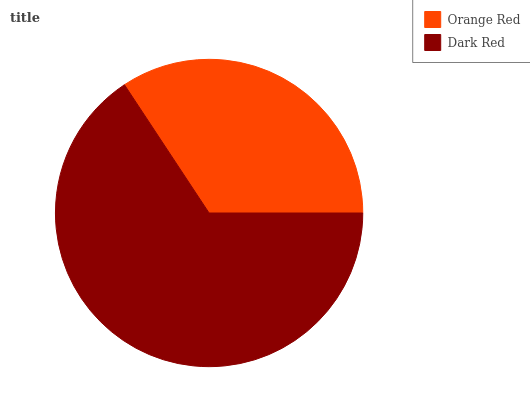Is Orange Red the minimum?
Answer yes or no. Yes. Is Dark Red the maximum?
Answer yes or no. Yes. Is Dark Red the minimum?
Answer yes or no. No. Is Dark Red greater than Orange Red?
Answer yes or no. Yes. Is Orange Red less than Dark Red?
Answer yes or no. Yes. Is Orange Red greater than Dark Red?
Answer yes or no. No. Is Dark Red less than Orange Red?
Answer yes or no. No. Is Dark Red the high median?
Answer yes or no. Yes. Is Orange Red the low median?
Answer yes or no. Yes. Is Orange Red the high median?
Answer yes or no. No. Is Dark Red the low median?
Answer yes or no. No. 